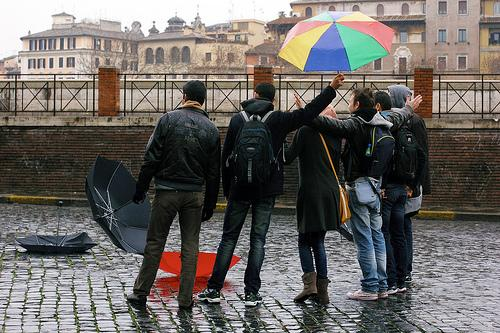Describe the umbrellas featured in the image. Multicolored and black umbrellas, some held in the air, others upside down on the wet brick road. Mention two contrasting objects in the image. A colorful open umbrella and an upside-down black umbrella. Describe any notable emotion of the people in the image. The mixed emotions of people dealing with wet weather, some with protection and others without. Briefly describe the setting of the image. A group of people on a wet cobblestone street with historic buildings in the background. Describe the image focusing on the accessories people are wearing or carrying. People have umbrellas, backpacks, sling bags, scarves, and purses in the wet, brick street scene. Summarize the overall scenario depicted in the image. A group of people stands on a wet brick street with umbrellas as they interact in front of historic buildings. Write a short sentence describing the weather in the image. The people and umbrellas indicate wet and rainy weather. Mention the most eye-catching object in the image. A multicolored umbrella being held in the air. Enumerate three notable objects found in the image. Multicolored umbrella, black umbrella on the ground, wet cobblestone bricks. Briefly describe the colors and textures present in the image. Bright, multicolored umbrellas contrast the dark, wet cobblestone bricks and historic buildings. 